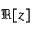Convert formula to latex. <formula><loc_0><loc_0><loc_500><loc_500>\Re [ z ]</formula> 